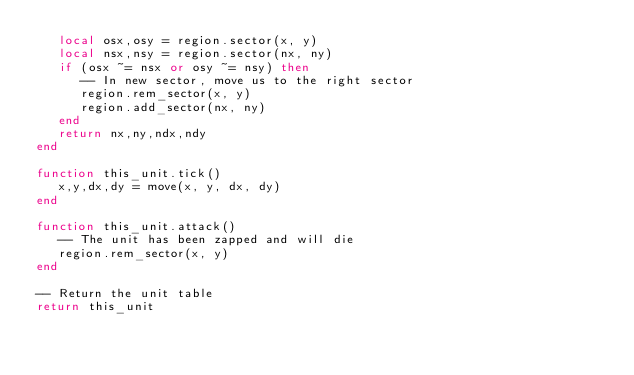Convert code to text. <code><loc_0><loc_0><loc_500><loc_500><_Lua_>   local osx,osy = region.sector(x, y)
   local nsx,nsy = region.sector(nx, ny)
   if (osx ~= nsx or osy ~= nsy) then
      -- In new sector, move us to the right sector
      region.rem_sector(x, y)
      region.add_sector(nx, ny)
   end
   return nx,ny,ndx,ndy
end

function this_unit.tick()
   x,y,dx,dy = move(x, y, dx, dy)
end

function this_unit.attack()
   -- The unit has been zapped and will die
   region.rem_sector(x, y)
end

-- Return the unit table
return this_unit
</code> 